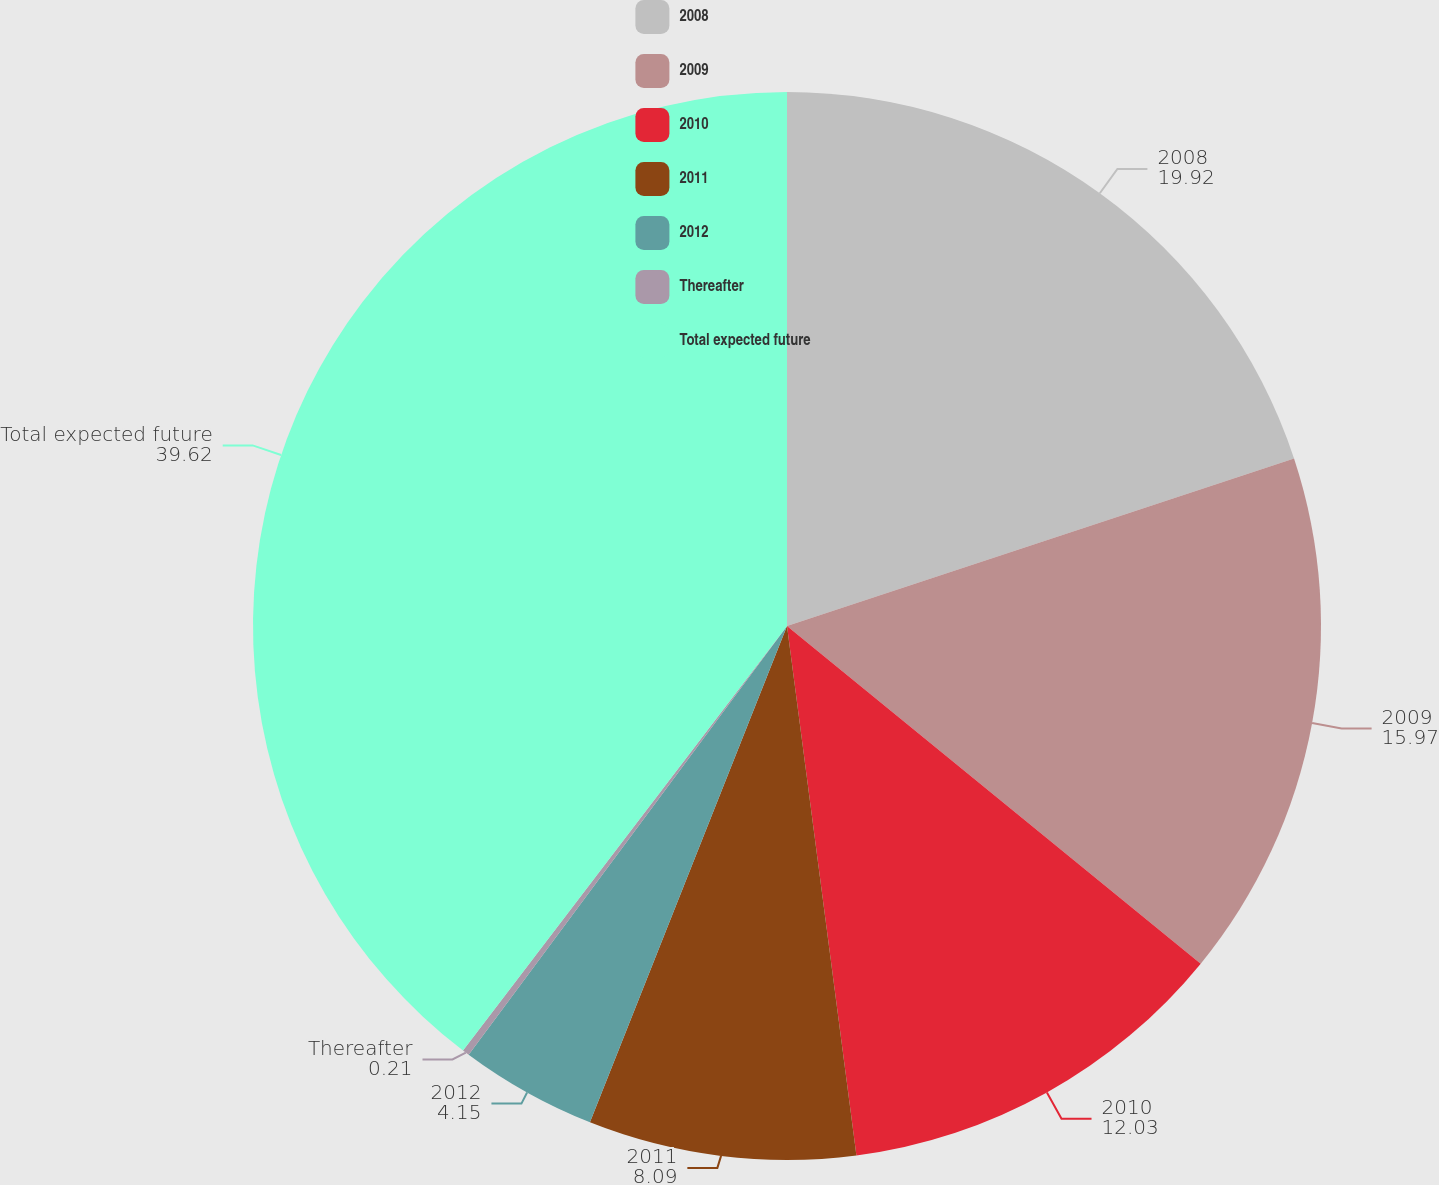Convert chart. <chart><loc_0><loc_0><loc_500><loc_500><pie_chart><fcel>2008<fcel>2009<fcel>2010<fcel>2011<fcel>2012<fcel>Thereafter<fcel>Total expected future<nl><fcel>19.92%<fcel>15.97%<fcel>12.03%<fcel>8.09%<fcel>4.15%<fcel>0.21%<fcel>39.62%<nl></chart> 